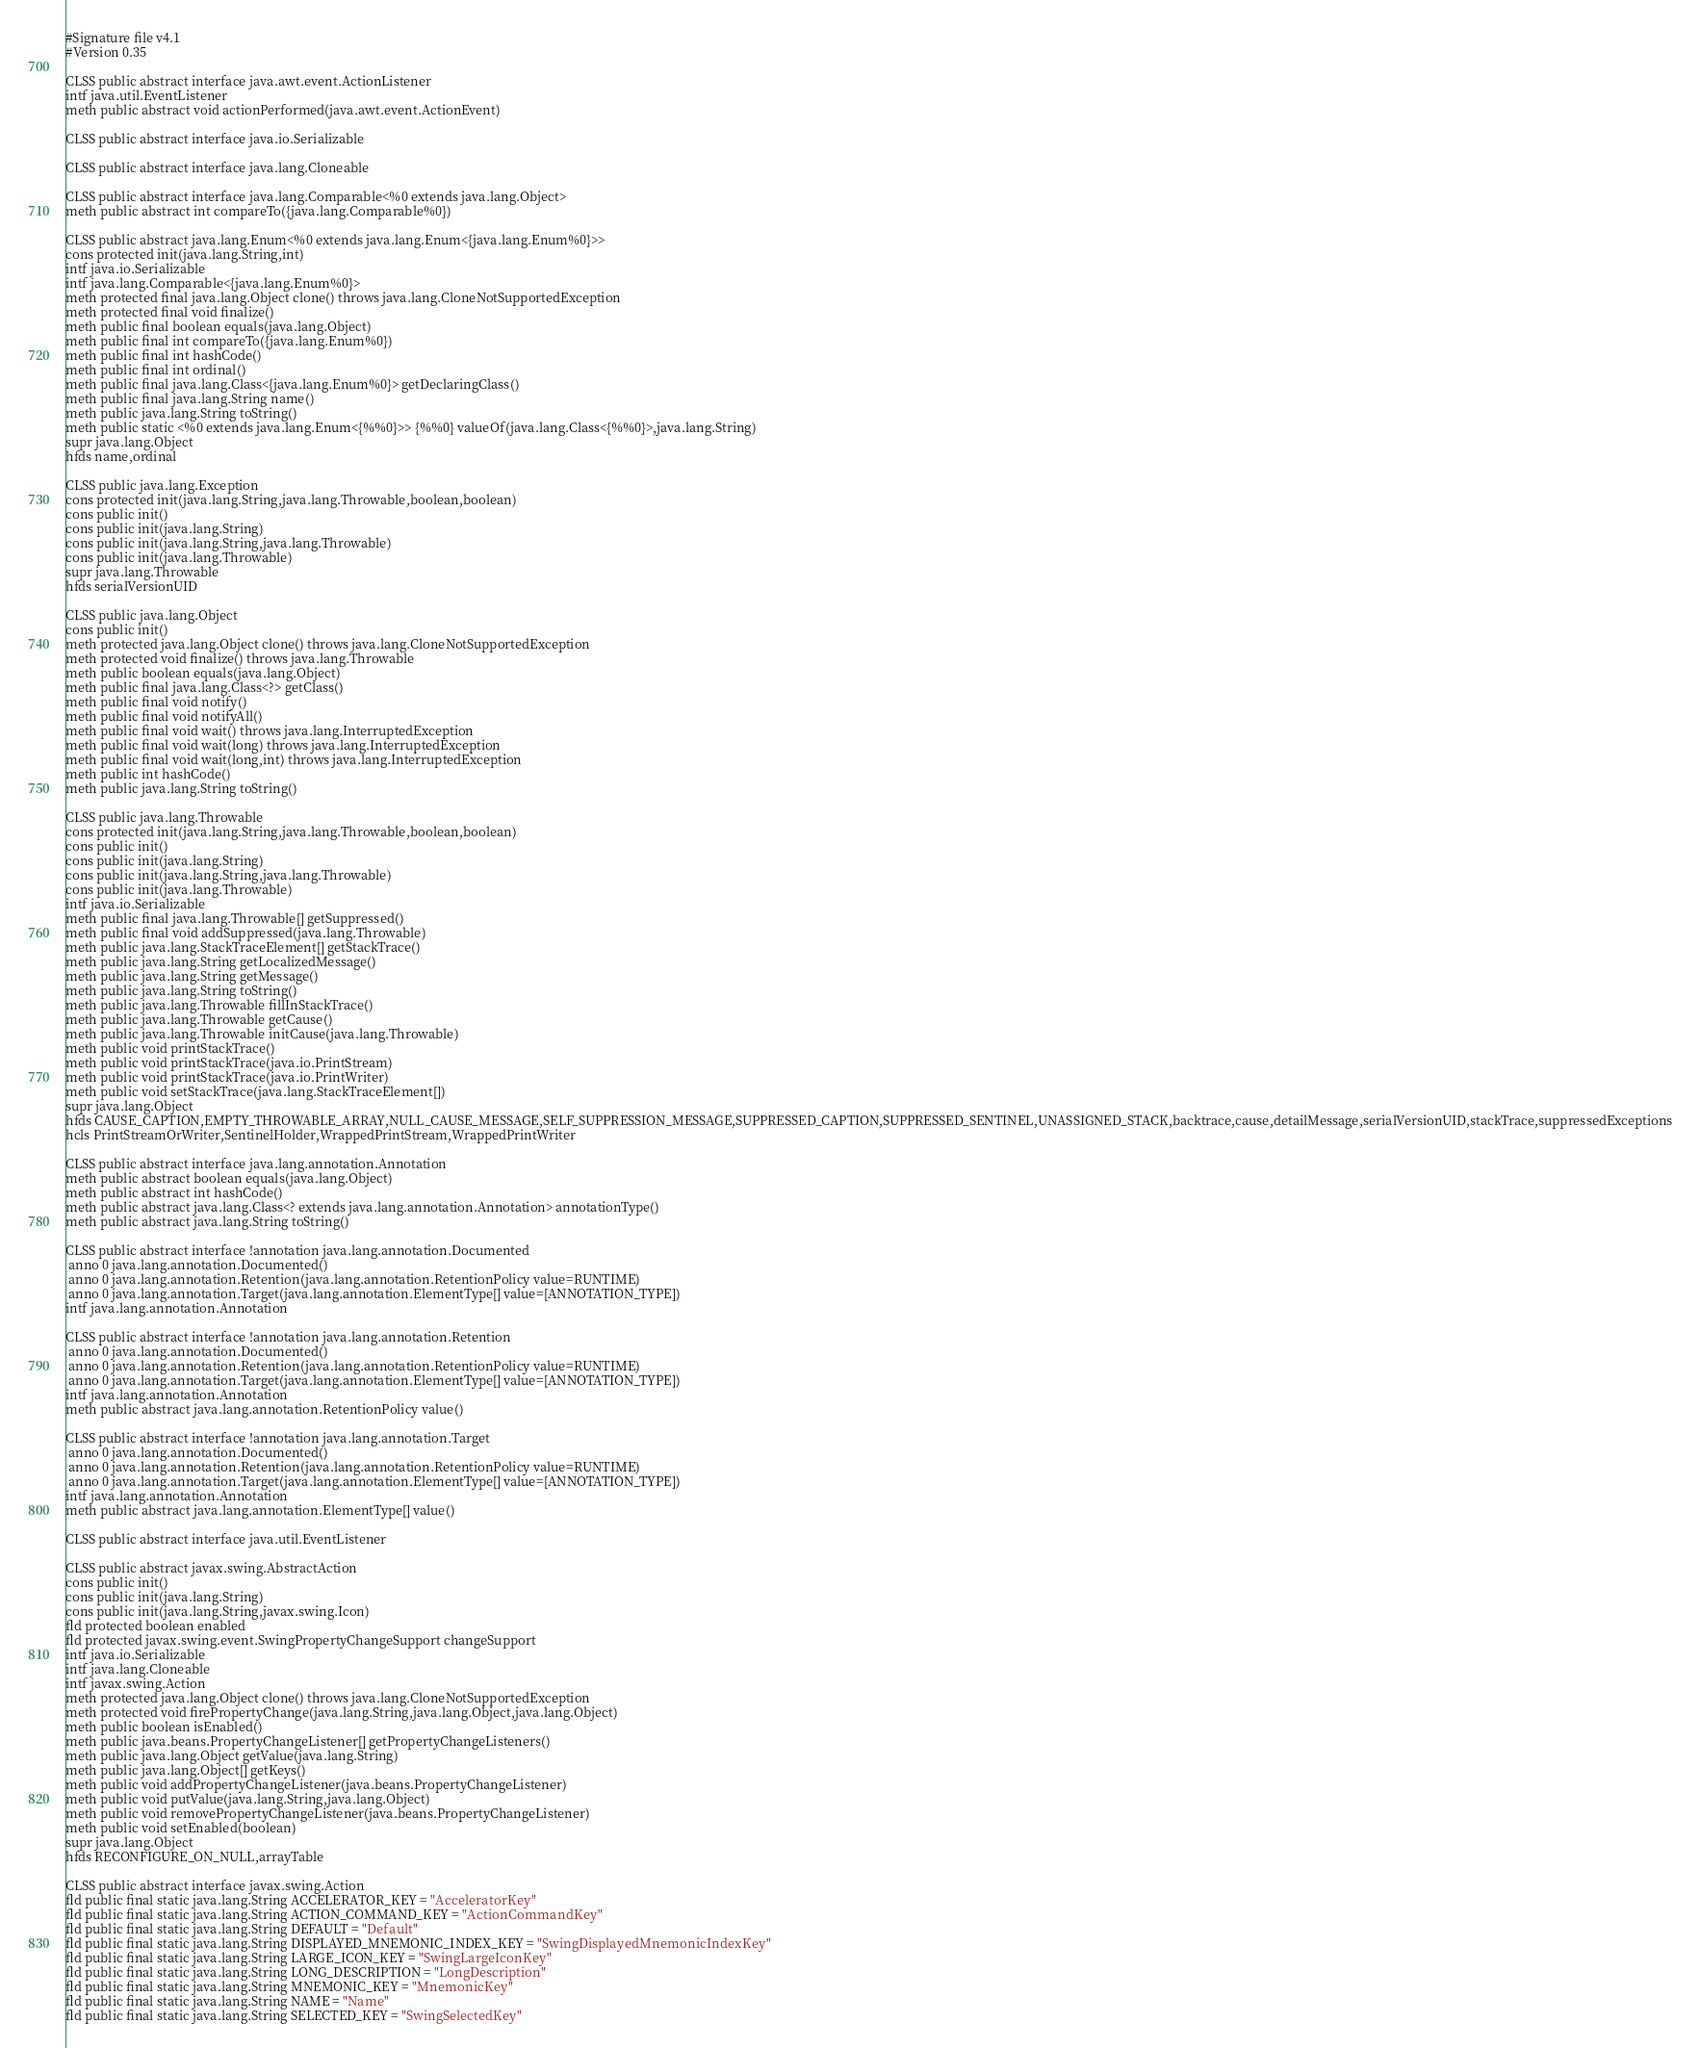Convert code to text. <code><loc_0><loc_0><loc_500><loc_500><_SML_>#Signature file v4.1
#Version 0.35

CLSS public abstract interface java.awt.event.ActionListener
intf java.util.EventListener
meth public abstract void actionPerformed(java.awt.event.ActionEvent)

CLSS public abstract interface java.io.Serializable

CLSS public abstract interface java.lang.Cloneable

CLSS public abstract interface java.lang.Comparable<%0 extends java.lang.Object>
meth public abstract int compareTo({java.lang.Comparable%0})

CLSS public abstract java.lang.Enum<%0 extends java.lang.Enum<{java.lang.Enum%0}>>
cons protected init(java.lang.String,int)
intf java.io.Serializable
intf java.lang.Comparable<{java.lang.Enum%0}>
meth protected final java.lang.Object clone() throws java.lang.CloneNotSupportedException
meth protected final void finalize()
meth public final boolean equals(java.lang.Object)
meth public final int compareTo({java.lang.Enum%0})
meth public final int hashCode()
meth public final int ordinal()
meth public final java.lang.Class<{java.lang.Enum%0}> getDeclaringClass()
meth public final java.lang.String name()
meth public java.lang.String toString()
meth public static <%0 extends java.lang.Enum<{%%0}>> {%%0} valueOf(java.lang.Class<{%%0}>,java.lang.String)
supr java.lang.Object
hfds name,ordinal

CLSS public java.lang.Exception
cons protected init(java.lang.String,java.lang.Throwable,boolean,boolean)
cons public init()
cons public init(java.lang.String)
cons public init(java.lang.String,java.lang.Throwable)
cons public init(java.lang.Throwable)
supr java.lang.Throwable
hfds serialVersionUID

CLSS public java.lang.Object
cons public init()
meth protected java.lang.Object clone() throws java.lang.CloneNotSupportedException
meth protected void finalize() throws java.lang.Throwable
meth public boolean equals(java.lang.Object)
meth public final java.lang.Class<?> getClass()
meth public final void notify()
meth public final void notifyAll()
meth public final void wait() throws java.lang.InterruptedException
meth public final void wait(long) throws java.lang.InterruptedException
meth public final void wait(long,int) throws java.lang.InterruptedException
meth public int hashCode()
meth public java.lang.String toString()

CLSS public java.lang.Throwable
cons protected init(java.lang.String,java.lang.Throwable,boolean,boolean)
cons public init()
cons public init(java.lang.String)
cons public init(java.lang.String,java.lang.Throwable)
cons public init(java.lang.Throwable)
intf java.io.Serializable
meth public final java.lang.Throwable[] getSuppressed()
meth public final void addSuppressed(java.lang.Throwable)
meth public java.lang.StackTraceElement[] getStackTrace()
meth public java.lang.String getLocalizedMessage()
meth public java.lang.String getMessage()
meth public java.lang.String toString()
meth public java.lang.Throwable fillInStackTrace()
meth public java.lang.Throwable getCause()
meth public java.lang.Throwable initCause(java.lang.Throwable)
meth public void printStackTrace()
meth public void printStackTrace(java.io.PrintStream)
meth public void printStackTrace(java.io.PrintWriter)
meth public void setStackTrace(java.lang.StackTraceElement[])
supr java.lang.Object
hfds CAUSE_CAPTION,EMPTY_THROWABLE_ARRAY,NULL_CAUSE_MESSAGE,SELF_SUPPRESSION_MESSAGE,SUPPRESSED_CAPTION,SUPPRESSED_SENTINEL,UNASSIGNED_STACK,backtrace,cause,detailMessage,serialVersionUID,stackTrace,suppressedExceptions
hcls PrintStreamOrWriter,SentinelHolder,WrappedPrintStream,WrappedPrintWriter

CLSS public abstract interface java.lang.annotation.Annotation
meth public abstract boolean equals(java.lang.Object)
meth public abstract int hashCode()
meth public abstract java.lang.Class<? extends java.lang.annotation.Annotation> annotationType()
meth public abstract java.lang.String toString()

CLSS public abstract interface !annotation java.lang.annotation.Documented
 anno 0 java.lang.annotation.Documented()
 anno 0 java.lang.annotation.Retention(java.lang.annotation.RetentionPolicy value=RUNTIME)
 anno 0 java.lang.annotation.Target(java.lang.annotation.ElementType[] value=[ANNOTATION_TYPE])
intf java.lang.annotation.Annotation

CLSS public abstract interface !annotation java.lang.annotation.Retention
 anno 0 java.lang.annotation.Documented()
 anno 0 java.lang.annotation.Retention(java.lang.annotation.RetentionPolicy value=RUNTIME)
 anno 0 java.lang.annotation.Target(java.lang.annotation.ElementType[] value=[ANNOTATION_TYPE])
intf java.lang.annotation.Annotation
meth public abstract java.lang.annotation.RetentionPolicy value()

CLSS public abstract interface !annotation java.lang.annotation.Target
 anno 0 java.lang.annotation.Documented()
 anno 0 java.lang.annotation.Retention(java.lang.annotation.RetentionPolicy value=RUNTIME)
 anno 0 java.lang.annotation.Target(java.lang.annotation.ElementType[] value=[ANNOTATION_TYPE])
intf java.lang.annotation.Annotation
meth public abstract java.lang.annotation.ElementType[] value()

CLSS public abstract interface java.util.EventListener

CLSS public abstract javax.swing.AbstractAction
cons public init()
cons public init(java.lang.String)
cons public init(java.lang.String,javax.swing.Icon)
fld protected boolean enabled
fld protected javax.swing.event.SwingPropertyChangeSupport changeSupport
intf java.io.Serializable
intf java.lang.Cloneable
intf javax.swing.Action
meth protected java.lang.Object clone() throws java.lang.CloneNotSupportedException
meth protected void firePropertyChange(java.lang.String,java.lang.Object,java.lang.Object)
meth public boolean isEnabled()
meth public java.beans.PropertyChangeListener[] getPropertyChangeListeners()
meth public java.lang.Object getValue(java.lang.String)
meth public java.lang.Object[] getKeys()
meth public void addPropertyChangeListener(java.beans.PropertyChangeListener)
meth public void putValue(java.lang.String,java.lang.Object)
meth public void removePropertyChangeListener(java.beans.PropertyChangeListener)
meth public void setEnabled(boolean)
supr java.lang.Object
hfds RECONFIGURE_ON_NULL,arrayTable

CLSS public abstract interface javax.swing.Action
fld public final static java.lang.String ACCELERATOR_KEY = "AcceleratorKey"
fld public final static java.lang.String ACTION_COMMAND_KEY = "ActionCommandKey"
fld public final static java.lang.String DEFAULT = "Default"
fld public final static java.lang.String DISPLAYED_MNEMONIC_INDEX_KEY = "SwingDisplayedMnemonicIndexKey"
fld public final static java.lang.String LARGE_ICON_KEY = "SwingLargeIconKey"
fld public final static java.lang.String LONG_DESCRIPTION = "LongDescription"
fld public final static java.lang.String MNEMONIC_KEY = "MnemonicKey"
fld public final static java.lang.String NAME = "Name"
fld public final static java.lang.String SELECTED_KEY = "SwingSelectedKey"</code> 